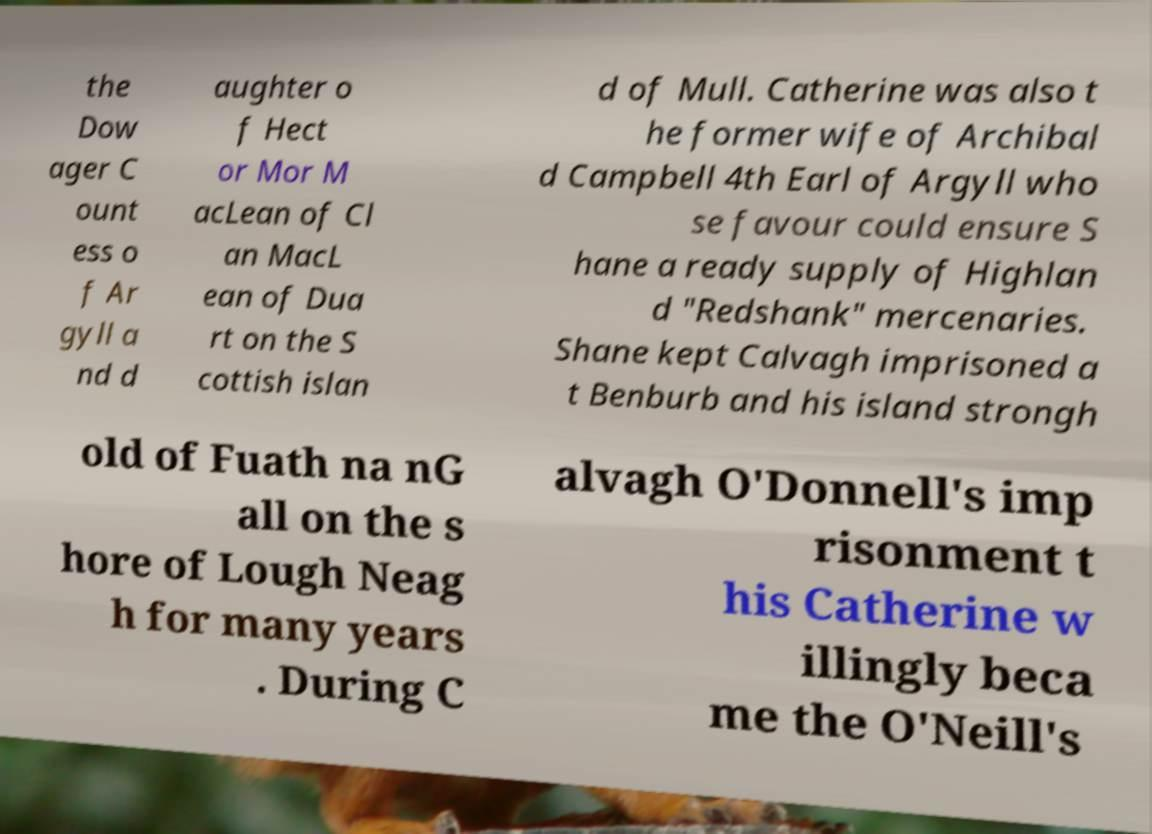Please identify and transcribe the text found in this image. the Dow ager C ount ess o f Ar gyll a nd d aughter o f Hect or Mor M acLean of Cl an MacL ean of Dua rt on the S cottish islan d of Mull. Catherine was also t he former wife of Archibal d Campbell 4th Earl of Argyll who se favour could ensure S hane a ready supply of Highlan d "Redshank" mercenaries. Shane kept Calvagh imprisoned a t Benburb and his island strongh old of Fuath na nG all on the s hore of Lough Neag h for many years . During C alvagh O'Donnell's imp risonment t his Catherine w illingly beca me the O'Neill's 